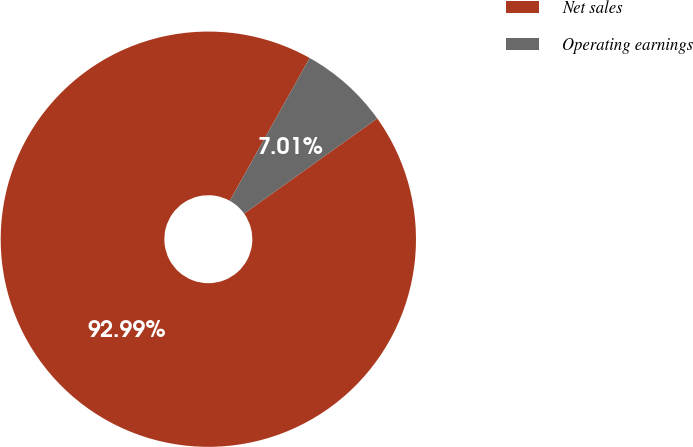Convert chart to OTSL. <chart><loc_0><loc_0><loc_500><loc_500><pie_chart><fcel>Net sales<fcel>Operating earnings<nl><fcel>92.99%<fcel>7.01%<nl></chart> 